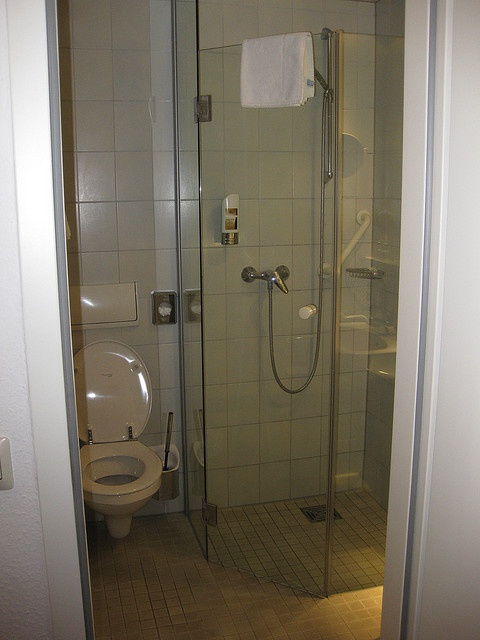Describe the objects in this image and their specific colors. I can see a toilet in lightgray, gray, and black tones in this image. 